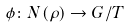<formula> <loc_0><loc_0><loc_500><loc_500>\phi \colon N ( \rho ) \rightarrow G / T</formula> 